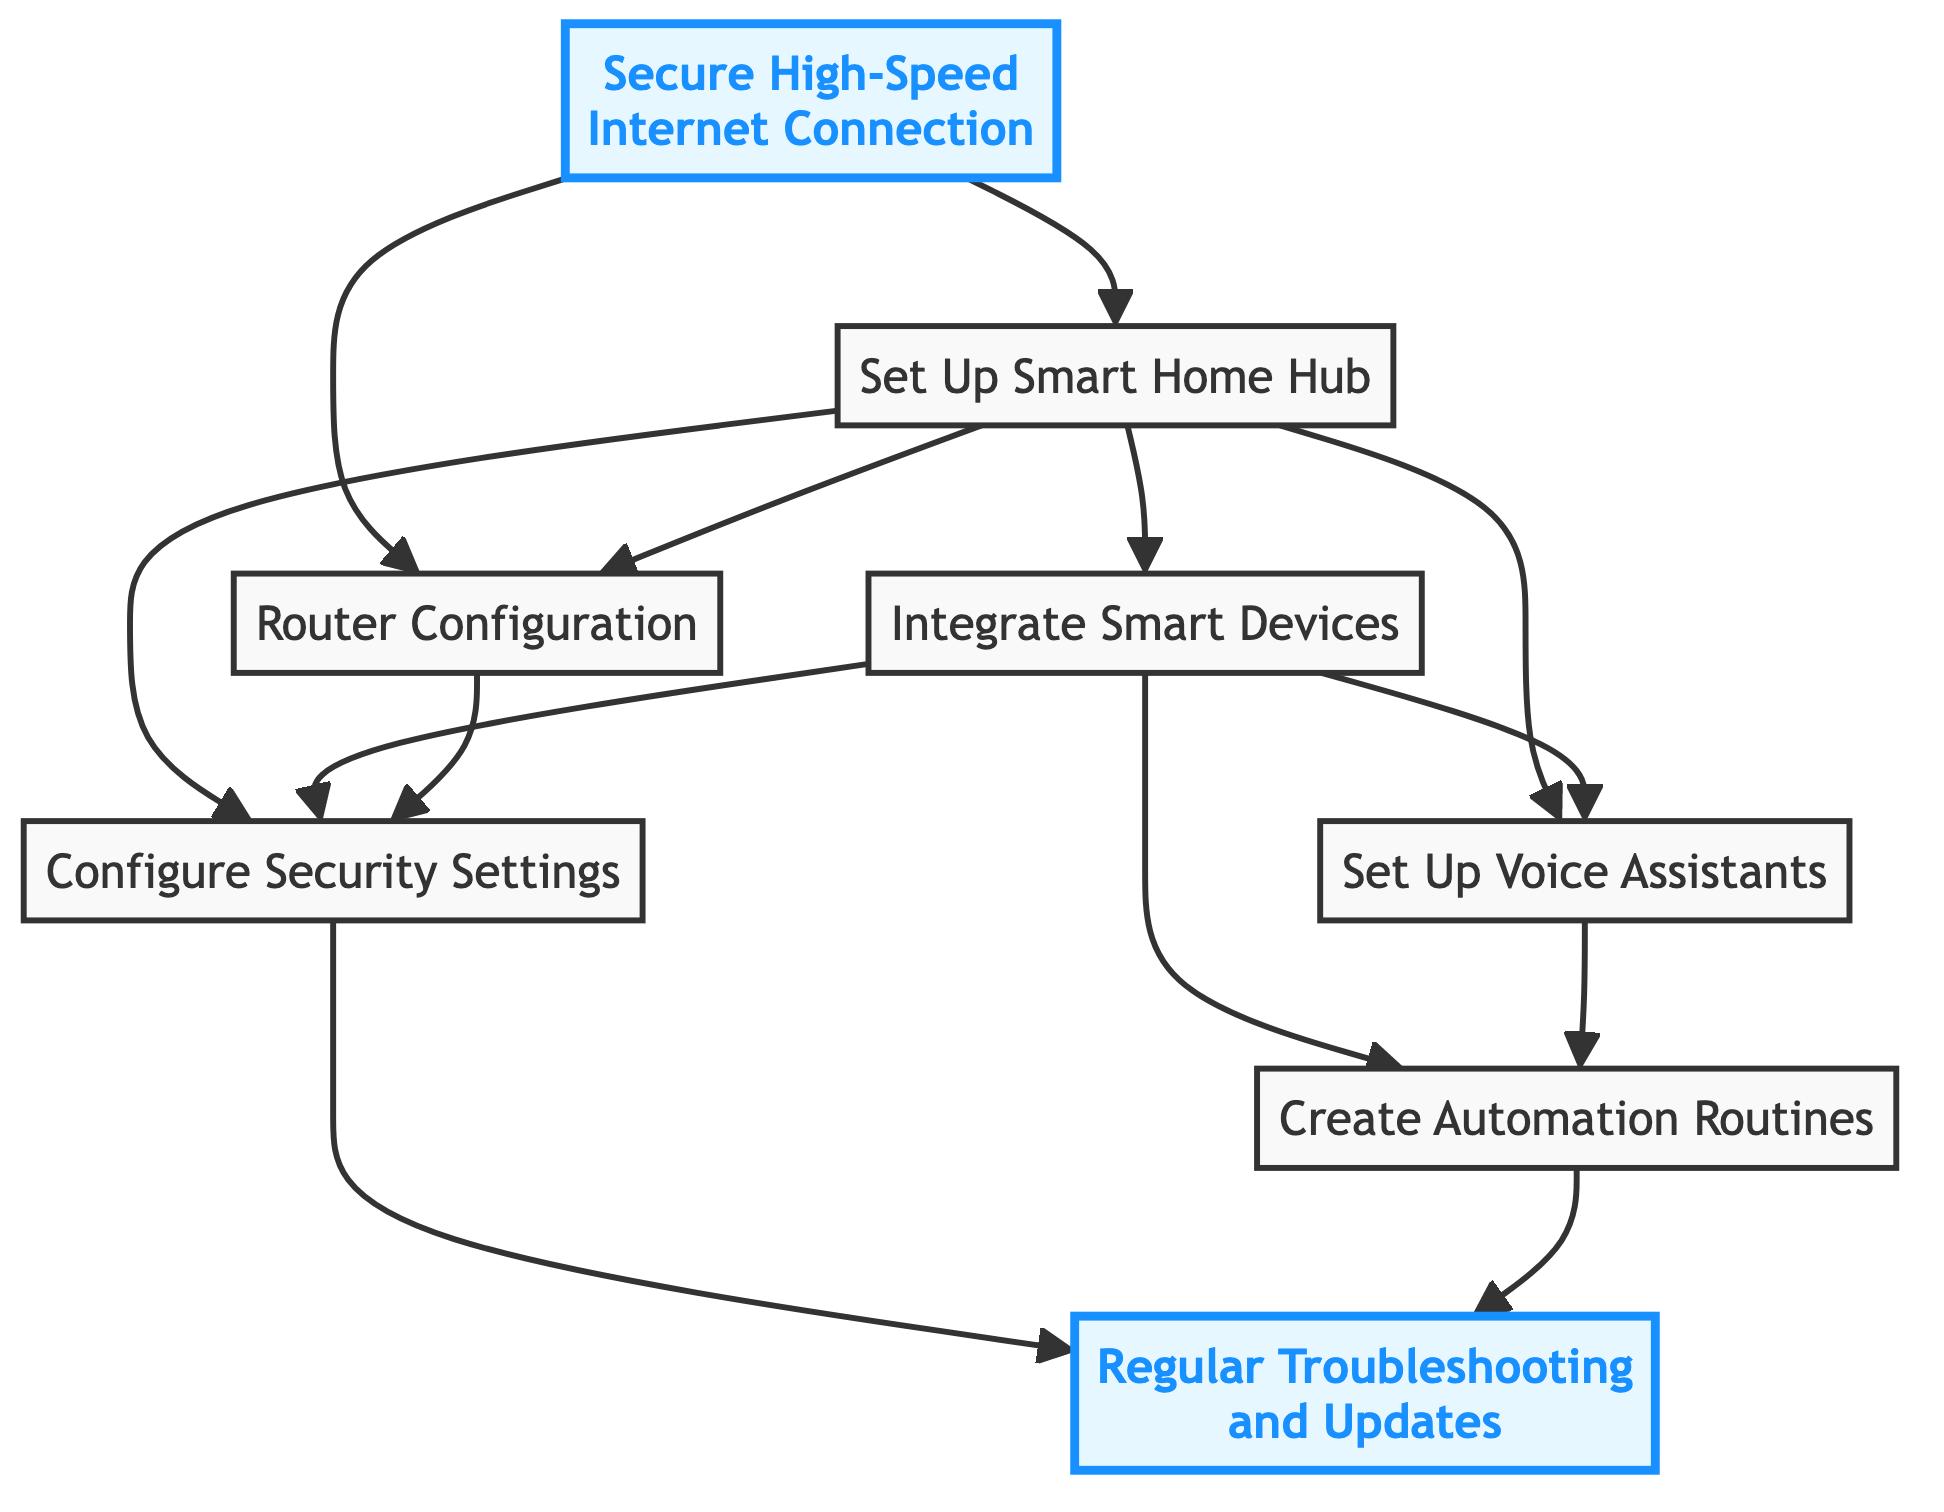What is the first step in setting up a smart home network? The diagram indicates that the first step is to establish a secure high-speed internet connection. This is the foundational step as all further actions depend on having reliable internet access.
Answer: Secure High-Speed Internet Connection How many main components are involved in the setup process? By counting the elements shown in the flowchart, there are eight main components connected in the setup process, starting from the internet connection to troubleshooting.
Answer: 8 What follows after setting up the smart home hub? After setting up the smart home hub, the next action is to configure the router, as indicated by the direct connection in the flowchart.
Answer: Router Configuration Which step requires both voice assistants and smart devices? The automation setup necessitates both voice assistants and smart devices, as shown by their connections leading into this step in the diagram, demonstrating the interdependencies.
Answer: Create Automation Routines What security measures are advised in the diagram? The diagram outlines that one should configure security settings, which include strong passwords, two-factor authentication, and network security, to protect smart home devices.
Answer: Configure Security Settings What is the final step in the smart home network setup? The last step indicated in the diagram is regular troubleshooting and updates, which ensures the continued functionality of the smart home network post-setup.
Answer: Regular Troubleshooting and Updates What are some examples of smart devices to integrate according to the diagram? The diagram suggests integrating smart lights, smart thermostats, and smart locks as examples of smart devices to be connected to the smart home hub in the process.
Answer: Smart lights, smart thermostats, smart locks Which two steps are connected directly to security settings? The steps directly connected to security settings are router configuration and smart devices; both play a crucial role in ensuring network protection as depicted in the diagram.
Answer: Router Configuration, Smart Devices 